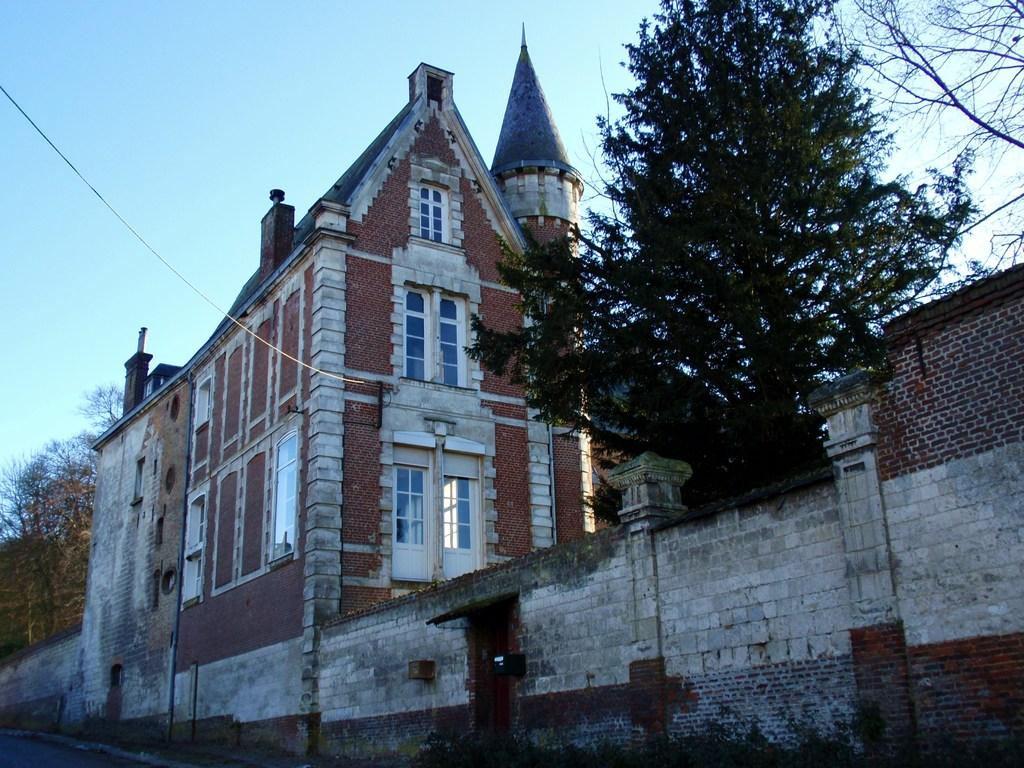What type of structure is visible in the image? There is a building in the image. What else can be seen in the image besides the building? There is a wall, trees, and a wire visible in the image. What is the condition of the sky in the background of the image? The sky is clear in the background of the image. What is the profit margin of the operation taking place in the image? There is no operation or profit margin mentioned in the image; it only shows a building, a wall, trees, a wire, and a clear sky in the background. 